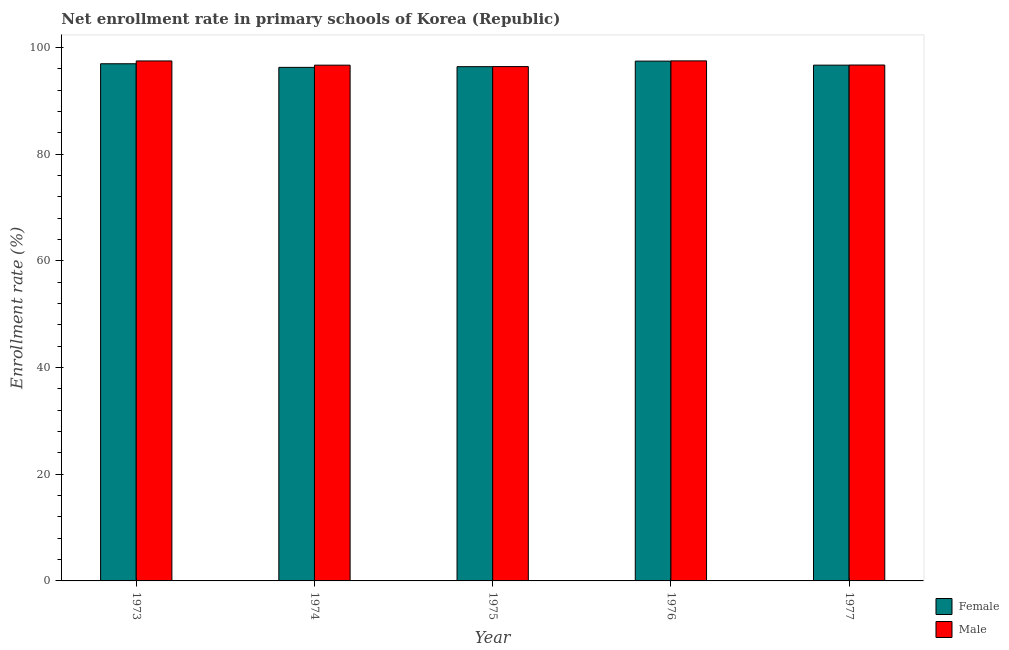How many different coloured bars are there?
Provide a short and direct response. 2. Are the number of bars per tick equal to the number of legend labels?
Give a very brief answer. Yes. Are the number of bars on each tick of the X-axis equal?
Make the answer very short. Yes. How many bars are there on the 1st tick from the left?
Offer a terse response. 2. What is the enrollment rate of male students in 1973?
Make the answer very short. 97.47. Across all years, what is the maximum enrollment rate of female students?
Give a very brief answer. 97.44. Across all years, what is the minimum enrollment rate of female students?
Give a very brief answer. 96.27. In which year was the enrollment rate of female students maximum?
Provide a short and direct response. 1976. In which year was the enrollment rate of male students minimum?
Offer a very short reply. 1975. What is the total enrollment rate of female students in the graph?
Provide a succinct answer. 483.75. What is the difference between the enrollment rate of male students in 1974 and that in 1976?
Offer a very short reply. -0.8. What is the difference between the enrollment rate of male students in 1974 and the enrollment rate of female students in 1976?
Provide a short and direct response. -0.8. What is the average enrollment rate of female students per year?
Your answer should be very brief. 96.75. What is the ratio of the enrollment rate of female students in 1973 to that in 1977?
Provide a short and direct response. 1. What is the difference between the highest and the second highest enrollment rate of female students?
Offer a very short reply. 0.49. What is the difference between the highest and the lowest enrollment rate of female students?
Ensure brevity in your answer.  1.17. Is the sum of the enrollment rate of male students in 1976 and 1977 greater than the maximum enrollment rate of female students across all years?
Your response must be concise. Yes. What does the 1st bar from the left in 1977 represents?
Give a very brief answer. Female. What does the 2nd bar from the right in 1973 represents?
Provide a succinct answer. Female. How many bars are there?
Ensure brevity in your answer.  10. What is the difference between two consecutive major ticks on the Y-axis?
Give a very brief answer. 20. Are the values on the major ticks of Y-axis written in scientific E-notation?
Provide a short and direct response. No. Does the graph contain grids?
Keep it short and to the point. No. Where does the legend appear in the graph?
Your response must be concise. Bottom right. How many legend labels are there?
Provide a succinct answer. 2. How are the legend labels stacked?
Give a very brief answer. Vertical. What is the title of the graph?
Make the answer very short. Net enrollment rate in primary schools of Korea (Republic). What is the label or title of the X-axis?
Offer a terse response. Year. What is the label or title of the Y-axis?
Your answer should be very brief. Enrollment rate (%). What is the Enrollment rate (%) of Female in 1973?
Your answer should be compact. 96.95. What is the Enrollment rate (%) of Male in 1973?
Provide a succinct answer. 97.47. What is the Enrollment rate (%) in Female in 1974?
Provide a succinct answer. 96.27. What is the Enrollment rate (%) in Male in 1974?
Give a very brief answer. 96.68. What is the Enrollment rate (%) in Female in 1975?
Your response must be concise. 96.4. What is the Enrollment rate (%) in Male in 1975?
Give a very brief answer. 96.42. What is the Enrollment rate (%) of Female in 1976?
Make the answer very short. 97.44. What is the Enrollment rate (%) of Male in 1976?
Your response must be concise. 97.49. What is the Enrollment rate (%) in Female in 1977?
Your response must be concise. 96.69. What is the Enrollment rate (%) in Male in 1977?
Your answer should be very brief. 96.71. Across all years, what is the maximum Enrollment rate (%) of Female?
Your answer should be very brief. 97.44. Across all years, what is the maximum Enrollment rate (%) of Male?
Your response must be concise. 97.49. Across all years, what is the minimum Enrollment rate (%) in Female?
Provide a succinct answer. 96.27. Across all years, what is the minimum Enrollment rate (%) in Male?
Ensure brevity in your answer.  96.42. What is the total Enrollment rate (%) of Female in the graph?
Your answer should be compact. 483.75. What is the total Enrollment rate (%) in Male in the graph?
Provide a short and direct response. 484.77. What is the difference between the Enrollment rate (%) in Female in 1973 and that in 1974?
Give a very brief answer. 0.68. What is the difference between the Enrollment rate (%) of Male in 1973 and that in 1974?
Give a very brief answer. 0.79. What is the difference between the Enrollment rate (%) of Female in 1973 and that in 1975?
Ensure brevity in your answer.  0.55. What is the difference between the Enrollment rate (%) of Male in 1973 and that in 1975?
Provide a succinct answer. 1.06. What is the difference between the Enrollment rate (%) of Female in 1973 and that in 1976?
Your response must be concise. -0.49. What is the difference between the Enrollment rate (%) in Male in 1973 and that in 1976?
Make the answer very short. -0.01. What is the difference between the Enrollment rate (%) in Female in 1973 and that in 1977?
Provide a succinct answer. 0.26. What is the difference between the Enrollment rate (%) of Male in 1973 and that in 1977?
Your answer should be very brief. 0.76. What is the difference between the Enrollment rate (%) of Female in 1974 and that in 1975?
Make the answer very short. -0.13. What is the difference between the Enrollment rate (%) of Male in 1974 and that in 1975?
Provide a succinct answer. 0.27. What is the difference between the Enrollment rate (%) of Female in 1974 and that in 1976?
Your answer should be compact. -1.17. What is the difference between the Enrollment rate (%) of Male in 1974 and that in 1976?
Your answer should be compact. -0.8. What is the difference between the Enrollment rate (%) in Female in 1974 and that in 1977?
Your response must be concise. -0.42. What is the difference between the Enrollment rate (%) in Male in 1974 and that in 1977?
Offer a very short reply. -0.03. What is the difference between the Enrollment rate (%) of Female in 1975 and that in 1976?
Give a very brief answer. -1.04. What is the difference between the Enrollment rate (%) in Male in 1975 and that in 1976?
Your response must be concise. -1.07. What is the difference between the Enrollment rate (%) of Female in 1975 and that in 1977?
Your answer should be very brief. -0.29. What is the difference between the Enrollment rate (%) of Male in 1975 and that in 1977?
Give a very brief answer. -0.29. What is the difference between the Enrollment rate (%) of Female in 1976 and that in 1977?
Ensure brevity in your answer.  0.76. What is the difference between the Enrollment rate (%) of Male in 1976 and that in 1977?
Your answer should be very brief. 0.78. What is the difference between the Enrollment rate (%) of Female in 1973 and the Enrollment rate (%) of Male in 1974?
Your answer should be very brief. 0.26. What is the difference between the Enrollment rate (%) in Female in 1973 and the Enrollment rate (%) in Male in 1975?
Your response must be concise. 0.53. What is the difference between the Enrollment rate (%) in Female in 1973 and the Enrollment rate (%) in Male in 1976?
Your answer should be compact. -0.54. What is the difference between the Enrollment rate (%) in Female in 1973 and the Enrollment rate (%) in Male in 1977?
Make the answer very short. 0.24. What is the difference between the Enrollment rate (%) of Female in 1974 and the Enrollment rate (%) of Male in 1975?
Keep it short and to the point. -0.15. What is the difference between the Enrollment rate (%) of Female in 1974 and the Enrollment rate (%) of Male in 1976?
Your response must be concise. -1.22. What is the difference between the Enrollment rate (%) in Female in 1974 and the Enrollment rate (%) in Male in 1977?
Offer a terse response. -0.44. What is the difference between the Enrollment rate (%) of Female in 1975 and the Enrollment rate (%) of Male in 1976?
Provide a succinct answer. -1.09. What is the difference between the Enrollment rate (%) in Female in 1975 and the Enrollment rate (%) in Male in 1977?
Provide a short and direct response. -0.31. What is the difference between the Enrollment rate (%) in Female in 1976 and the Enrollment rate (%) in Male in 1977?
Give a very brief answer. 0.73. What is the average Enrollment rate (%) in Female per year?
Provide a short and direct response. 96.75. What is the average Enrollment rate (%) of Male per year?
Ensure brevity in your answer.  96.95. In the year 1973, what is the difference between the Enrollment rate (%) in Female and Enrollment rate (%) in Male?
Offer a very short reply. -0.53. In the year 1974, what is the difference between the Enrollment rate (%) of Female and Enrollment rate (%) of Male?
Offer a terse response. -0.41. In the year 1975, what is the difference between the Enrollment rate (%) in Female and Enrollment rate (%) in Male?
Provide a short and direct response. -0.02. In the year 1976, what is the difference between the Enrollment rate (%) of Female and Enrollment rate (%) of Male?
Make the answer very short. -0.05. In the year 1977, what is the difference between the Enrollment rate (%) in Female and Enrollment rate (%) in Male?
Offer a very short reply. -0.02. What is the ratio of the Enrollment rate (%) of Female in 1973 to that in 1974?
Offer a very short reply. 1.01. What is the ratio of the Enrollment rate (%) in Male in 1973 to that in 1974?
Give a very brief answer. 1.01. What is the ratio of the Enrollment rate (%) in Female in 1973 to that in 1975?
Ensure brevity in your answer.  1.01. What is the ratio of the Enrollment rate (%) in Female in 1973 to that in 1976?
Ensure brevity in your answer.  0.99. What is the ratio of the Enrollment rate (%) of Male in 1973 to that in 1976?
Provide a succinct answer. 1. What is the ratio of the Enrollment rate (%) in Female in 1973 to that in 1977?
Offer a terse response. 1. What is the ratio of the Enrollment rate (%) in Male in 1973 to that in 1977?
Your answer should be very brief. 1.01. What is the ratio of the Enrollment rate (%) in Female in 1974 to that in 1975?
Your response must be concise. 1. What is the ratio of the Enrollment rate (%) in Male in 1974 to that in 1975?
Provide a succinct answer. 1. What is the ratio of the Enrollment rate (%) in Female in 1974 to that in 1976?
Your answer should be very brief. 0.99. What is the ratio of the Enrollment rate (%) in Male in 1974 to that in 1976?
Your answer should be compact. 0.99. What is the ratio of the Enrollment rate (%) in Female in 1974 to that in 1977?
Provide a short and direct response. 1. What is the ratio of the Enrollment rate (%) in Male in 1974 to that in 1977?
Give a very brief answer. 1. What is the ratio of the Enrollment rate (%) in Female in 1975 to that in 1976?
Keep it short and to the point. 0.99. What is the ratio of the Enrollment rate (%) of Male in 1975 to that in 1976?
Your response must be concise. 0.99. What is the ratio of the Enrollment rate (%) of Female in 1975 to that in 1977?
Your answer should be compact. 1. What is the ratio of the Enrollment rate (%) of Female in 1976 to that in 1977?
Your answer should be very brief. 1.01. What is the ratio of the Enrollment rate (%) in Male in 1976 to that in 1977?
Keep it short and to the point. 1.01. What is the difference between the highest and the second highest Enrollment rate (%) in Female?
Ensure brevity in your answer.  0.49. What is the difference between the highest and the second highest Enrollment rate (%) of Male?
Your answer should be compact. 0.01. What is the difference between the highest and the lowest Enrollment rate (%) of Female?
Offer a very short reply. 1.17. What is the difference between the highest and the lowest Enrollment rate (%) of Male?
Ensure brevity in your answer.  1.07. 